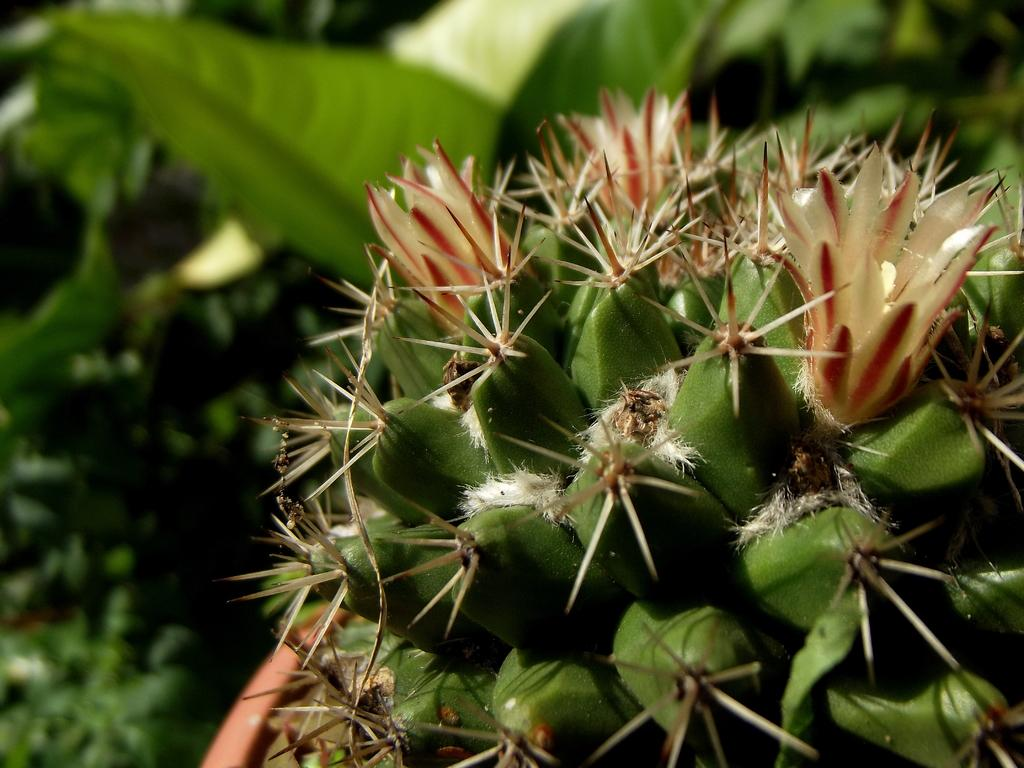What type of flora can be seen in the image? There are flowers in the image. What colors are the flowers? The flowers are red and cream in color. Where are the flowers located? The flowers are on a plant. What is the color of the plant? The plant is green in color. What can be seen in the background of the image? There are trees in the background of the image. What is the color of the trees? The trees are green in color. What direction are the flowers facing in the image? The flowers' direction cannot be determined from the image, as they are not shown facing a specific direction. Is there a vase present in the image? No, there is no vase present in the image; the flowers are on a plant. 